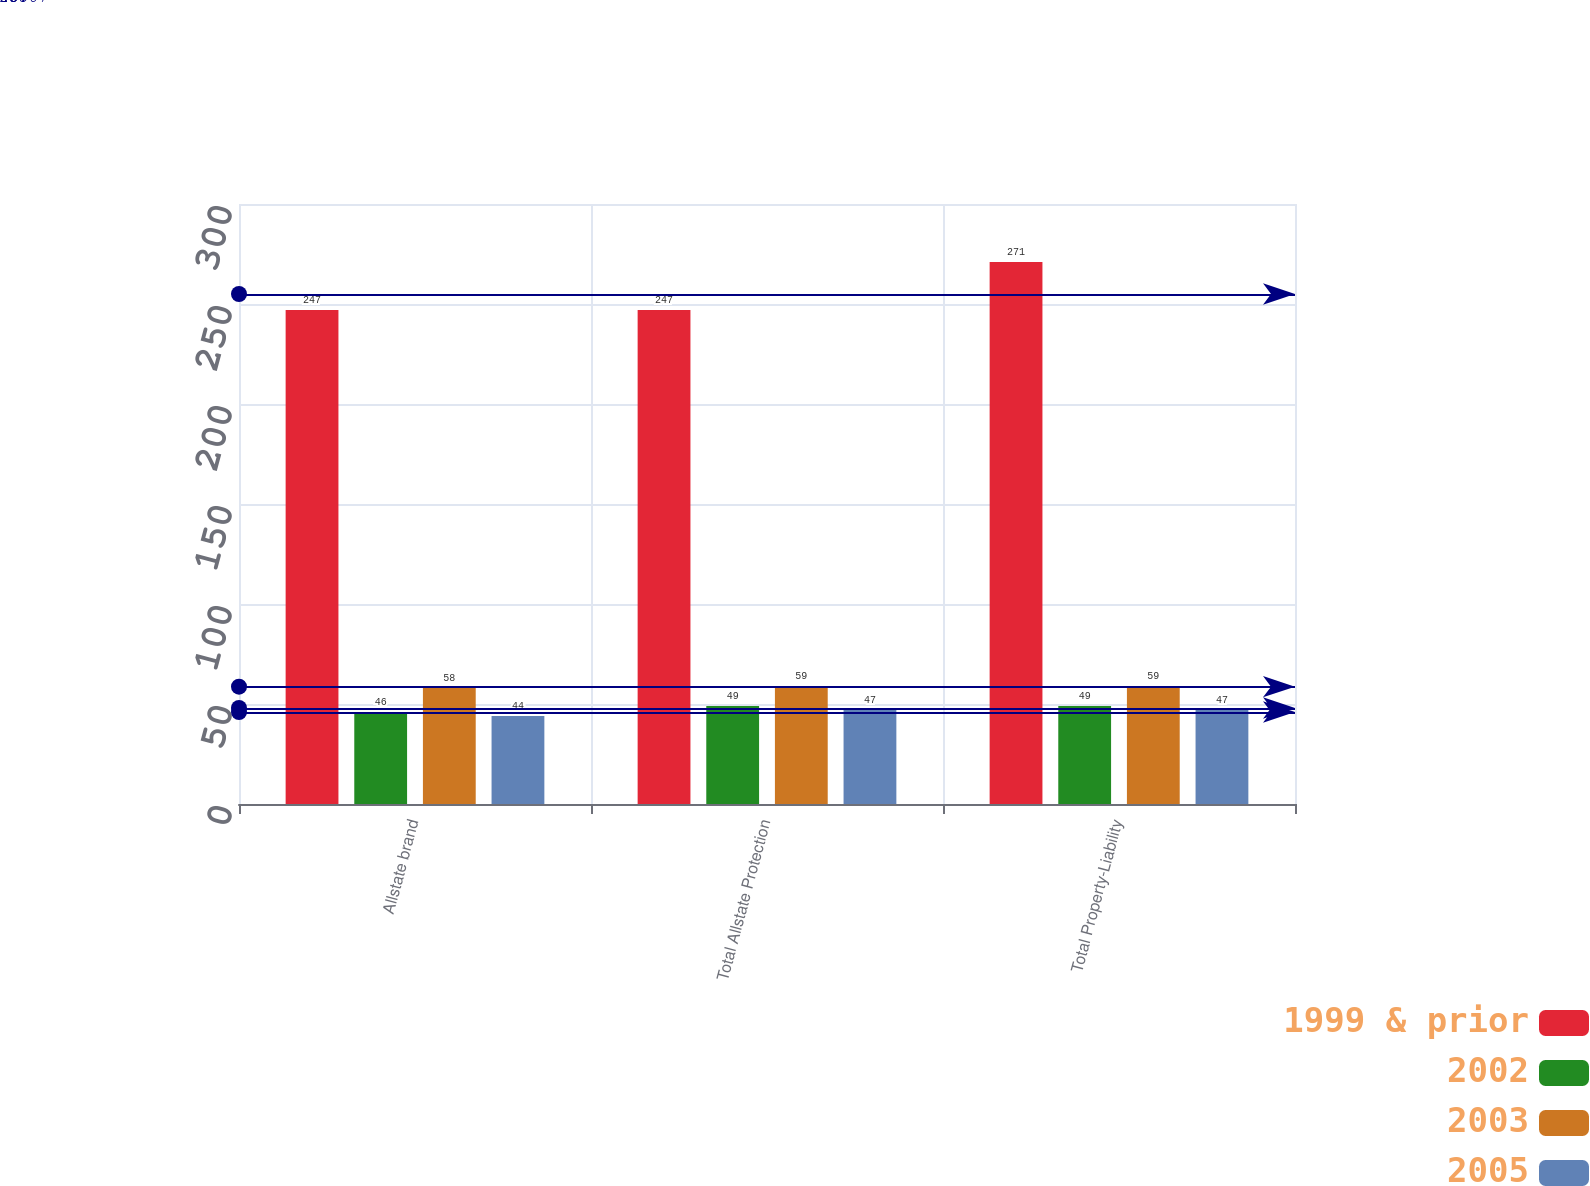<chart> <loc_0><loc_0><loc_500><loc_500><stacked_bar_chart><ecel><fcel>Allstate brand<fcel>Total Allstate Protection<fcel>Total Property-Liability<nl><fcel>1999 & prior<fcel>247<fcel>247<fcel>271<nl><fcel>2002<fcel>46<fcel>49<fcel>49<nl><fcel>2003<fcel>58<fcel>59<fcel>59<nl><fcel>2005<fcel>44<fcel>47<fcel>47<nl></chart> 